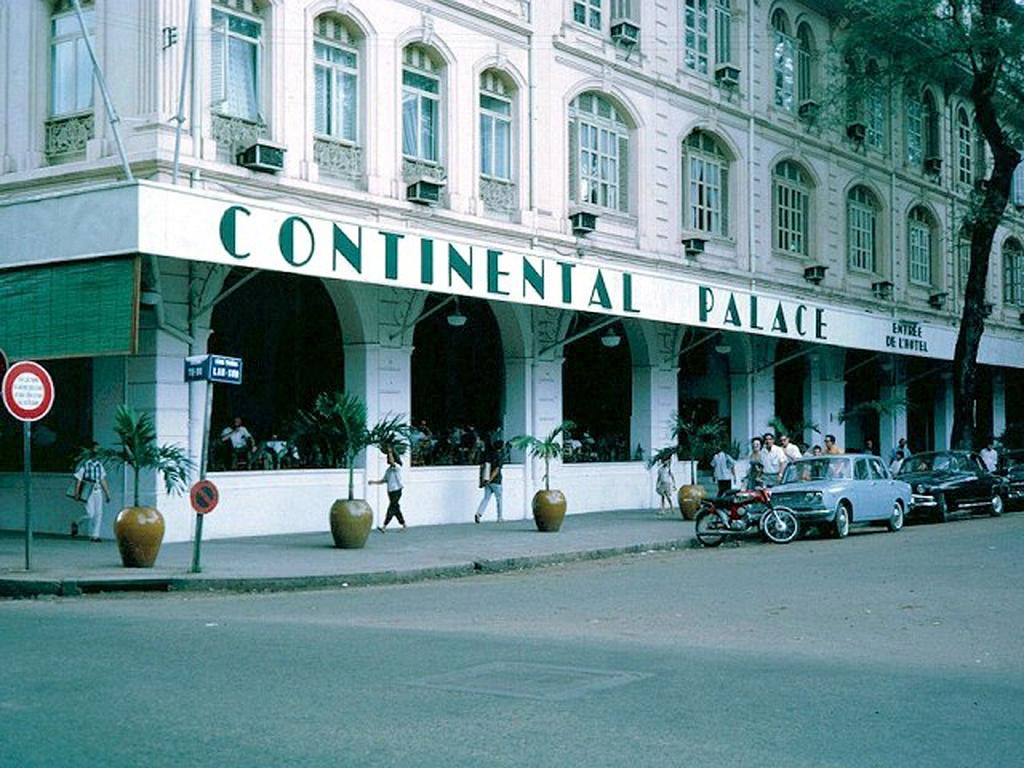What can be seen parked on the path in the image? There are vehicles parked on the path in the image. What type of natural elements are visible in the image? There are plants and a tree visible in the image. What type of infrastructure is present in the image? There is a road, sign boards, and at least one building in the image. What are the people in the image doing? There is a group of people walking on the sidewalk in the image. Can you describe the furniture in the image? There is no furniture present in the image. What type of beast can be seen interacting with the group of people walking on the sidewalk? There is no beast present in the image; only the vehicles, plants, road, sign boards, building, and people are visible. 